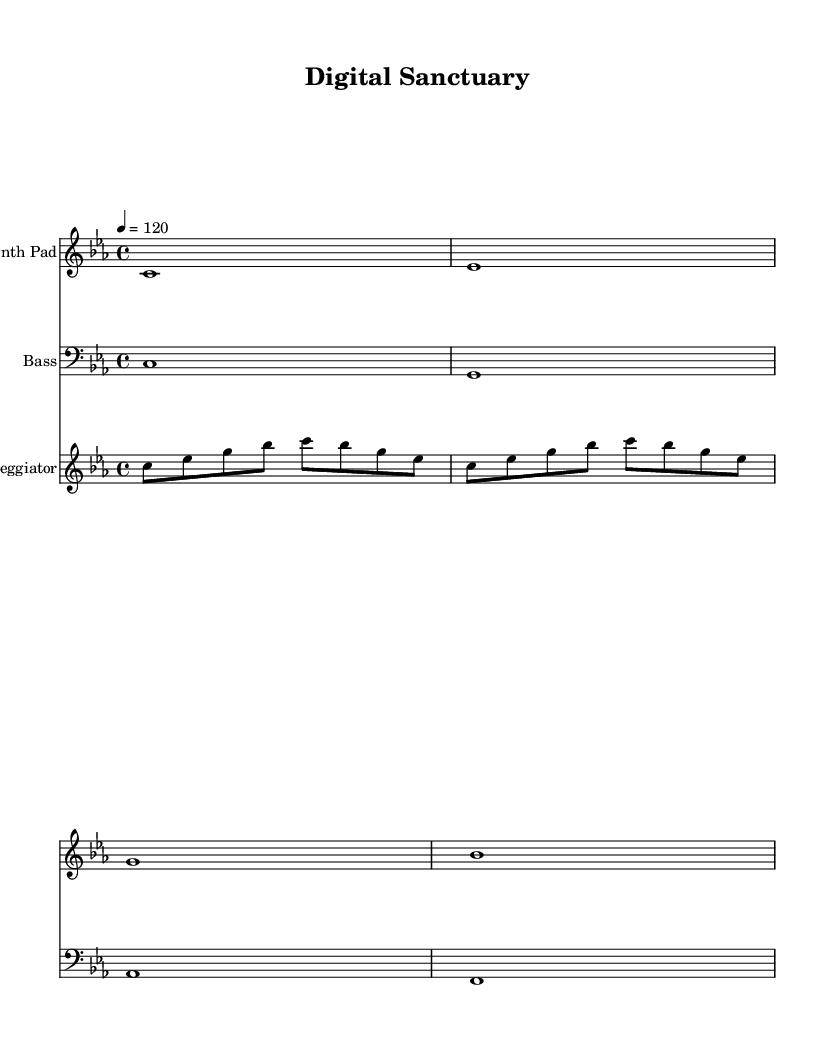What is the key signature of this music? The key signature is indicated by the key signature notation at the beginning of the staff. In this case, it is C minor, which has three flats (B flat, E flat, A flat).
Answer: C minor What is the time signature of this music? The time signature is indicated by the numbers at the beginning of the sheet music. Here, it shows 4 over 4, meaning there are four beats in a measure and the quarter note gets one beat.
Answer: 4/4 What is the tempo marking for this piece? The tempo marking is found near the top and indicates how fast the piece should be played. Here, it states a tempo of 120 beats per minute.
Answer: 120 How many instruments are used in this piece? By counting the individual staves labeled with different instrument names, we see there are three distinct staves: Synth Pad, Bass, and Arpeggiator, thus indicating three instruments.
Answer: 3 What note is played at the start of the Synth Pad staff? Looking at the first note of the Synth Pad line, it is a C note, which is clearly marked as the initial note in the sequence.
Answer: C Which musical patterns define the arpeggiator section? The arpeggiator section consists of a repeating pattern of notes, specifically a sequence of C, E flat, G, B flat, and then again at C, demonstrating the arpeggiated chords structure typical in Ambient House tracks.
Answer: C, E flat, G, B flat 